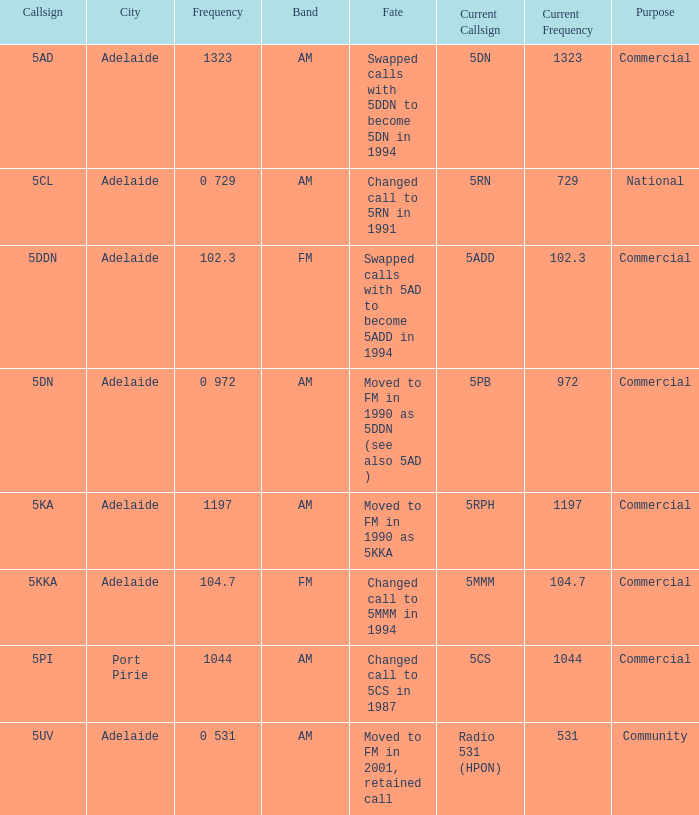What is the purpose for Frequency of 102.3? Commercial. 